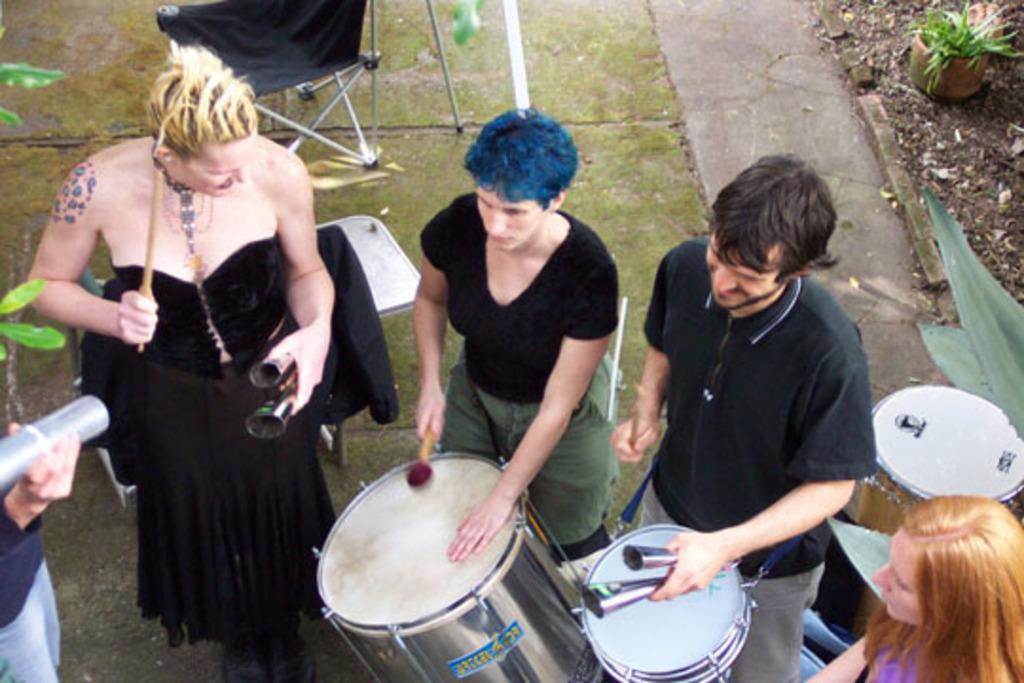In one or two sentences, can you explain what this image depicts? One woman wearing a black dress is holding a stick. Beside to her two persons are holding drums and sticks. One lady is there. There is a stand. One table is behind them. In the background there is a pot with a plant. 